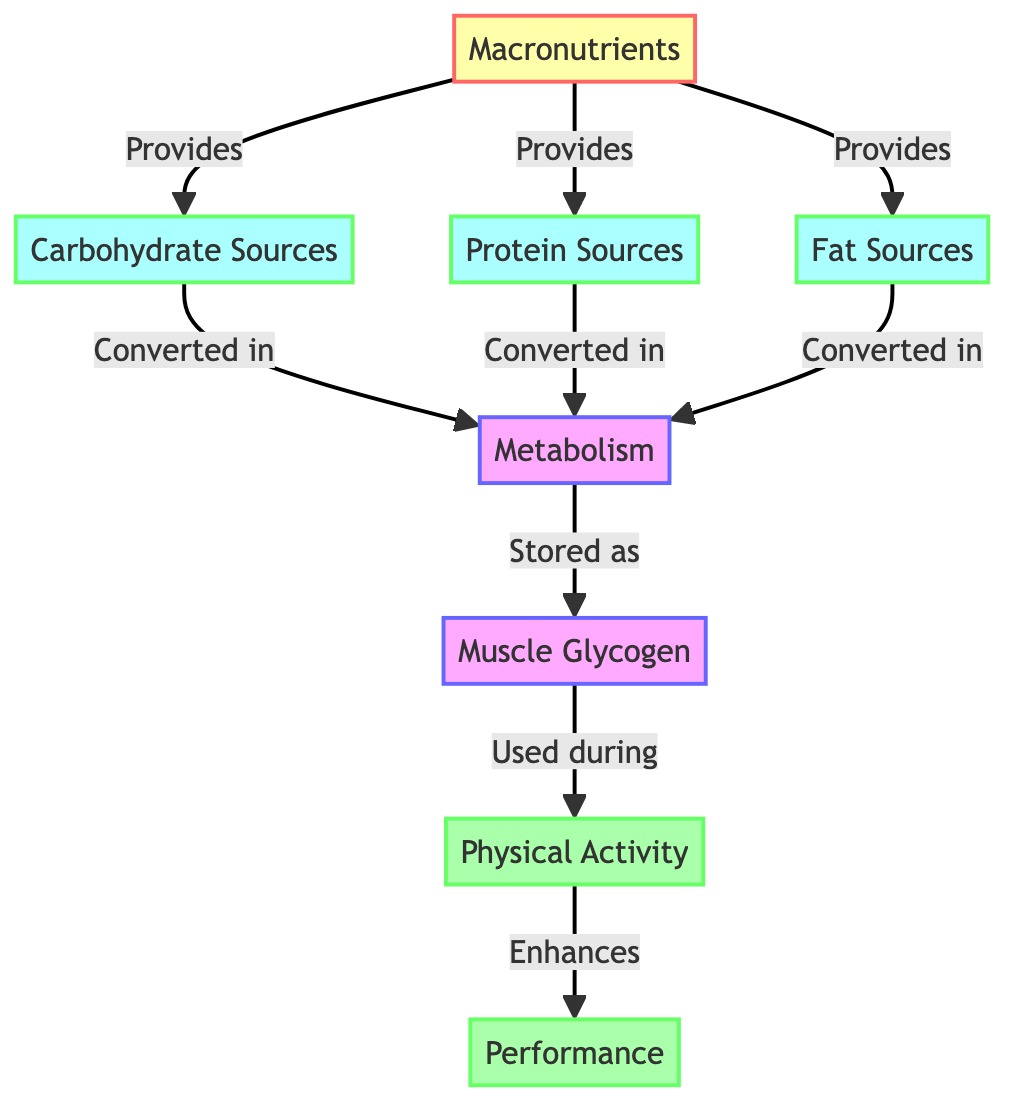What are the three sources of macronutrients in the diagram? The diagram lists three sources under "Macronutrients": Carbohydrate Sources, Protein Sources, and Fat Sources.
Answer: Carbohydrate Sources, Protein Sources, Fat Sources What does metabolism convert the macronutrient sources into? The diagram shows that metabolism converts Carbohydrate, Protein, and Fat Sources into energy, which is stored as Muscle Glycogen.
Answer: Energy How many nodes are in the diagram? Counting each labeled node in the diagram, there are a total of eight distinct nodes representing various stages and components of the food chain.
Answer: Eight What enhances performance according to the diagram? The flowchart indicates that physical activity, which is used during muscle glycogen utilization, enhances performance on the court.
Answer: Physical activity Which node is connected directly to muscle glycogen? The diagram shows a direct connection from metabolism to muscle glycogen, indicating that energy is stored there.
Answer: Metabolism Which macronutrient source provides energy for metabolism? The diagram displays that all three types of macronutrient sources provide energy for metabolism, meaning carbohydrates, proteins, and fats can all contribute.
Answer: All sources How is energy categorized in this food chain? The diagram categorizes energy derived from macronutrients through the process of metabolism and stores it as muscle glycogen before being used for physical activity.
Answer: Stored as muscle glycogen What is the flow of energy from muscle glycogen during basketball performance? The flow starts with muscle glycogen being used during physical activity, which enhances performance according to the diagram.
Answer: From muscle glycogen to physical activity to performance 